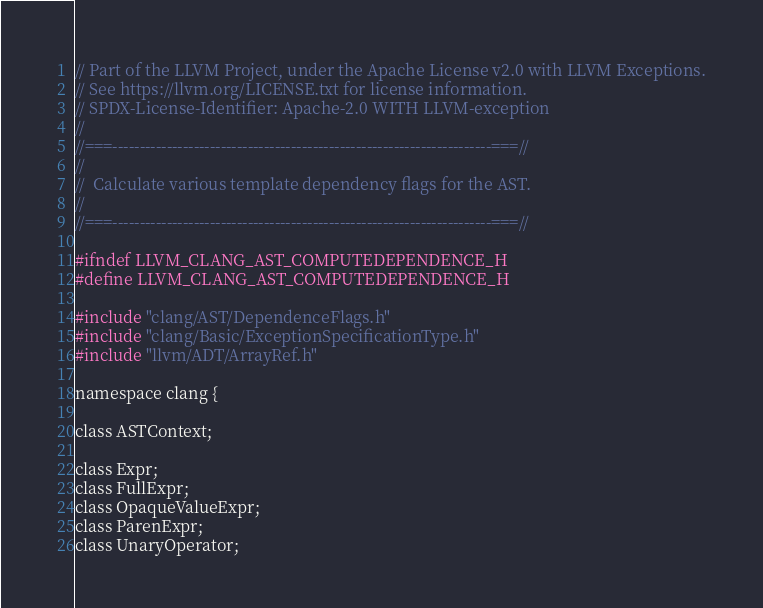Convert code to text. <code><loc_0><loc_0><loc_500><loc_500><_C_>// Part of the LLVM Project, under the Apache License v2.0 with LLVM Exceptions.
// See https://llvm.org/LICENSE.txt for license information.
// SPDX-License-Identifier: Apache-2.0 WITH LLVM-exception
//
//===----------------------------------------------------------------------===//
//
//  Calculate various template dependency flags for the AST.
//
//===----------------------------------------------------------------------===//

#ifndef LLVM_CLANG_AST_COMPUTEDEPENDENCE_H
#define LLVM_CLANG_AST_COMPUTEDEPENDENCE_H

#include "clang/AST/DependenceFlags.h"
#include "clang/Basic/ExceptionSpecificationType.h"
#include "llvm/ADT/ArrayRef.h"

namespace clang {

class ASTContext;

class Expr;
class FullExpr;
class OpaqueValueExpr;
class ParenExpr;
class UnaryOperator;</code> 